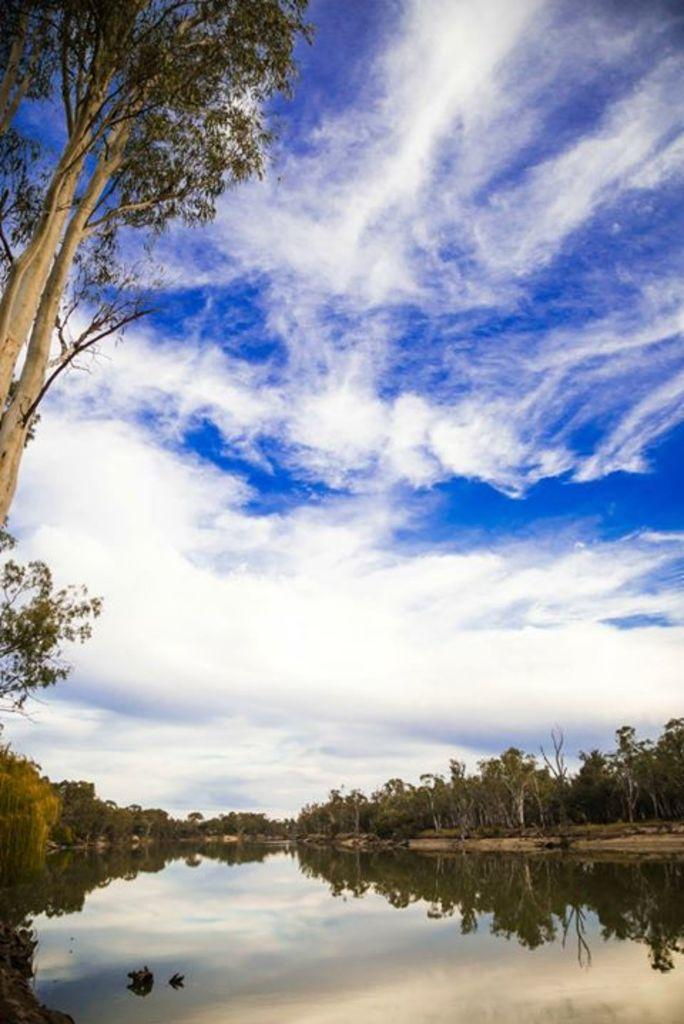What is visible in the image? Water, trees, and clouds are visible in the image. Can you describe the natural elements in the image? The image features water, trees, and clouds, which are all part of the natural environment. What type of vegetation is present in the image? Trees are present in the image. How many birds are sitting on the nest in the image? There is no nest or birds present in the image; it features water, trees, and clouds. 